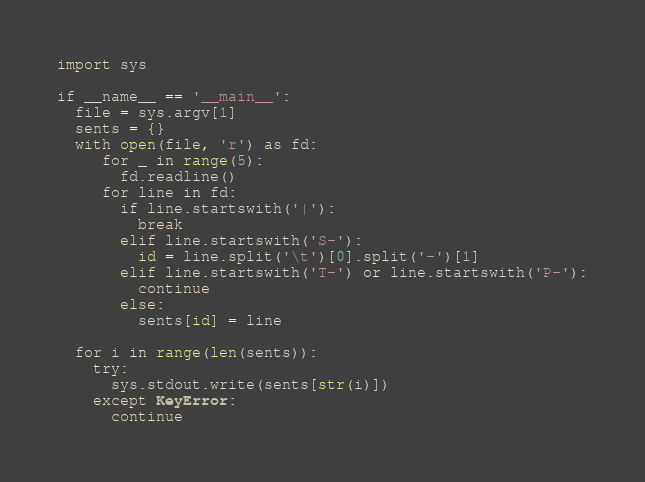Convert code to text. <code><loc_0><loc_0><loc_500><loc_500><_Python_>import sys

if __name__ == '__main__':
  file = sys.argv[1]
  sents = {}
  with open(file, 'r') as fd:
     for _ in range(5):
       fd.readline()
     for line in fd:
       if line.startswith('|'):
         break
       elif line.startswith('S-'):
         id = line.split('\t')[0].split('-')[1]
       elif line.startswith('T-') or line.startswith('P-'):
         continue
       else:
         sents[id] = line

  for i in range(len(sents)):
    try:
      sys.stdout.write(sents[str(i)])
    except KeyError:
      continue
</code> 